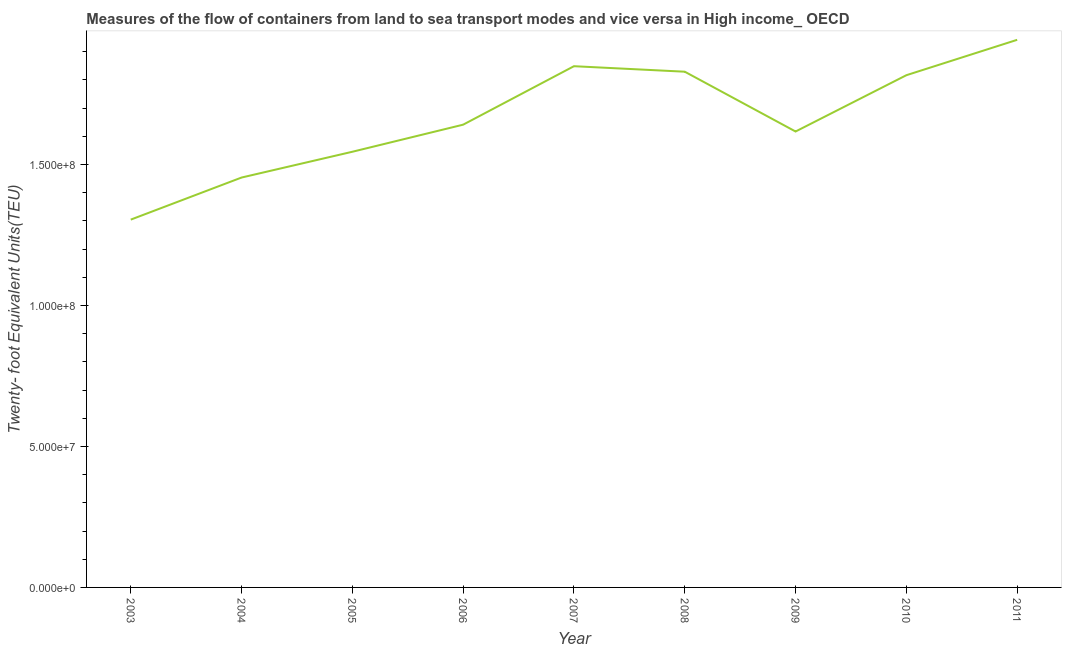What is the container port traffic in 2006?
Keep it short and to the point. 1.64e+08. Across all years, what is the maximum container port traffic?
Your answer should be compact. 1.94e+08. Across all years, what is the minimum container port traffic?
Offer a very short reply. 1.30e+08. In which year was the container port traffic maximum?
Make the answer very short. 2011. In which year was the container port traffic minimum?
Provide a succinct answer. 2003. What is the sum of the container port traffic?
Offer a terse response. 1.50e+09. What is the difference between the container port traffic in 2009 and 2010?
Your answer should be compact. -2.00e+07. What is the average container port traffic per year?
Your answer should be very brief. 1.67e+08. What is the median container port traffic?
Keep it short and to the point. 1.64e+08. What is the ratio of the container port traffic in 2010 to that in 2011?
Your answer should be very brief. 0.94. Is the container port traffic in 2003 less than that in 2007?
Your answer should be compact. Yes. Is the difference between the container port traffic in 2007 and 2009 greater than the difference between any two years?
Your answer should be very brief. No. What is the difference between the highest and the second highest container port traffic?
Give a very brief answer. 9.36e+06. Is the sum of the container port traffic in 2007 and 2011 greater than the maximum container port traffic across all years?
Your answer should be compact. Yes. What is the difference between the highest and the lowest container port traffic?
Provide a short and direct response. 6.38e+07. How many lines are there?
Your answer should be compact. 1. How many years are there in the graph?
Your response must be concise. 9. Are the values on the major ticks of Y-axis written in scientific E-notation?
Provide a short and direct response. Yes. Does the graph contain any zero values?
Make the answer very short. No. What is the title of the graph?
Your response must be concise. Measures of the flow of containers from land to sea transport modes and vice versa in High income_ OECD. What is the label or title of the Y-axis?
Your answer should be compact. Twenty- foot Equivalent Units(TEU). What is the Twenty- foot Equivalent Units(TEU) in 2003?
Keep it short and to the point. 1.30e+08. What is the Twenty- foot Equivalent Units(TEU) in 2004?
Make the answer very short. 1.45e+08. What is the Twenty- foot Equivalent Units(TEU) of 2005?
Make the answer very short. 1.55e+08. What is the Twenty- foot Equivalent Units(TEU) of 2006?
Your answer should be very brief. 1.64e+08. What is the Twenty- foot Equivalent Units(TEU) of 2007?
Offer a terse response. 1.85e+08. What is the Twenty- foot Equivalent Units(TEU) of 2008?
Provide a succinct answer. 1.83e+08. What is the Twenty- foot Equivalent Units(TEU) of 2009?
Provide a succinct answer. 1.62e+08. What is the Twenty- foot Equivalent Units(TEU) of 2010?
Give a very brief answer. 1.82e+08. What is the Twenty- foot Equivalent Units(TEU) in 2011?
Provide a succinct answer. 1.94e+08. What is the difference between the Twenty- foot Equivalent Units(TEU) in 2003 and 2004?
Provide a short and direct response. -1.49e+07. What is the difference between the Twenty- foot Equivalent Units(TEU) in 2003 and 2005?
Make the answer very short. -2.41e+07. What is the difference between the Twenty- foot Equivalent Units(TEU) in 2003 and 2006?
Your answer should be compact. -3.37e+07. What is the difference between the Twenty- foot Equivalent Units(TEU) in 2003 and 2007?
Make the answer very short. -5.44e+07. What is the difference between the Twenty- foot Equivalent Units(TEU) in 2003 and 2008?
Keep it short and to the point. -5.25e+07. What is the difference between the Twenty- foot Equivalent Units(TEU) in 2003 and 2009?
Provide a succinct answer. -3.13e+07. What is the difference between the Twenty- foot Equivalent Units(TEU) in 2003 and 2010?
Your answer should be very brief. -5.12e+07. What is the difference between the Twenty- foot Equivalent Units(TEU) in 2003 and 2011?
Your answer should be very brief. -6.38e+07. What is the difference between the Twenty- foot Equivalent Units(TEU) in 2004 and 2005?
Offer a terse response. -9.14e+06. What is the difference between the Twenty- foot Equivalent Units(TEU) in 2004 and 2006?
Keep it short and to the point. -1.88e+07. What is the difference between the Twenty- foot Equivalent Units(TEU) in 2004 and 2007?
Give a very brief answer. -3.95e+07. What is the difference between the Twenty- foot Equivalent Units(TEU) in 2004 and 2008?
Keep it short and to the point. -3.75e+07. What is the difference between the Twenty- foot Equivalent Units(TEU) in 2004 and 2009?
Keep it short and to the point. -1.63e+07. What is the difference between the Twenty- foot Equivalent Units(TEU) in 2004 and 2010?
Your answer should be very brief. -3.63e+07. What is the difference between the Twenty- foot Equivalent Units(TEU) in 2004 and 2011?
Your answer should be compact. -4.88e+07. What is the difference between the Twenty- foot Equivalent Units(TEU) in 2005 and 2006?
Keep it short and to the point. -9.61e+06. What is the difference between the Twenty- foot Equivalent Units(TEU) in 2005 and 2007?
Your response must be concise. -3.03e+07. What is the difference between the Twenty- foot Equivalent Units(TEU) in 2005 and 2008?
Provide a succinct answer. -2.84e+07. What is the difference between the Twenty- foot Equivalent Units(TEU) in 2005 and 2009?
Make the answer very short. -7.18e+06. What is the difference between the Twenty- foot Equivalent Units(TEU) in 2005 and 2010?
Make the answer very short. -2.72e+07. What is the difference between the Twenty- foot Equivalent Units(TEU) in 2005 and 2011?
Provide a succinct answer. -3.97e+07. What is the difference between the Twenty- foot Equivalent Units(TEU) in 2006 and 2007?
Give a very brief answer. -2.07e+07. What is the difference between the Twenty- foot Equivalent Units(TEU) in 2006 and 2008?
Give a very brief answer. -1.88e+07. What is the difference between the Twenty- foot Equivalent Units(TEU) in 2006 and 2009?
Give a very brief answer. 2.42e+06. What is the difference between the Twenty- foot Equivalent Units(TEU) in 2006 and 2010?
Offer a terse response. -1.75e+07. What is the difference between the Twenty- foot Equivalent Units(TEU) in 2006 and 2011?
Your answer should be very brief. -3.01e+07. What is the difference between the Twenty- foot Equivalent Units(TEU) in 2007 and 2008?
Ensure brevity in your answer.  1.95e+06. What is the difference between the Twenty- foot Equivalent Units(TEU) in 2007 and 2009?
Ensure brevity in your answer.  2.32e+07. What is the difference between the Twenty- foot Equivalent Units(TEU) in 2007 and 2010?
Make the answer very short. 3.19e+06. What is the difference between the Twenty- foot Equivalent Units(TEU) in 2007 and 2011?
Keep it short and to the point. -9.36e+06. What is the difference between the Twenty- foot Equivalent Units(TEU) in 2008 and 2009?
Offer a very short reply. 2.12e+07. What is the difference between the Twenty- foot Equivalent Units(TEU) in 2008 and 2010?
Offer a terse response. 1.24e+06. What is the difference between the Twenty- foot Equivalent Units(TEU) in 2008 and 2011?
Give a very brief answer. -1.13e+07. What is the difference between the Twenty- foot Equivalent Units(TEU) in 2009 and 2010?
Your response must be concise. -2.00e+07. What is the difference between the Twenty- foot Equivalent Units(TEU) in 2009 and 2011?
Keep it short and to the point. -3.25e+07. What is the difference between the Twenty- foot Equivalent Units(TEU) in 2010 and 2011?
Your answer should be very brief. -1.25e+07. What is the ratio of the Twenty- foot Equivalent Units(TEU) in 2003 to that in 2004?
Your answer should be compact. 0.9. What is the ratio of the Twenty- foot Equivalent Units(TEU) in 2003 to that in 2005?
Offer a terse response. 0.84. What is the ratio of the Twenty- foot Equivalent Units(TEU) in 2003 to that in 2006?
Provide a succinct answer. 0.8. What is the ratio of the Twenty- foot Equivalent Units(TEU) in 2003 to that in 2007?
Your response must be concise. 0.71. What is the ratio of the Twenty- foot Equivalent Units(TEU) in 2003 to that in 2008?
Ensure brevity in your answer.  0.71. What is the ratio of the Twenty- foot Equivalent Units(TEU) in 2003 to that in 2009?
Your response must be concise. 0.81. What is the ratio of the Twenty- foot Equivalent Units(TEU) in 2003 to that in 2010?
Provide a succinct answer. 0.72. What is the ratio of the Twenty- foot Equivalent Units(TEU) in 2003 to that in 2011?
Offer a very short reply. 0.67. What is the ratio of the Twenty- foot Equivalent Units(TEU) in 2004 to that in 2005?
Your response must be concise. 0.94. What is the ratio of the Twenty- foot Equivalent Units(TEU) in 2004 to that in 2006?
Make the answer very short. 0.89. What is the ratio of the Twenty- foot Equivalent Units(TEU) in 2004 to that in 2007?
Offer a very short reply. 0.79. What is the ratio of the Twenty- foot Equivalent Units(TEU) in 2004 to that in 2008?
Make the answer very short. 0.8. What is the ratio of the Twenty- foot Equivalent Units(TEU) in 2004 to that in 2009?
Offer a very short reply. 0.9. What is the ratio of the Twenty- foot Equivalent Units(TEU) in 2004 to that in 2011?
Offer a terse response. 0.75. What is the ratio of the Twenty- foot Equivalent Units(TEU) in 2005 to that in 2006?
Offer a very short reply. 0.94. What is the ratio of the Twenty- foot Equivalent Units(TEU) in 2005 to that in 2007?
Give a very brief answer. 0.84. What is the ratio of the Twenty- foot Equivalent Units(TEU) in 2005 to that in 2008?
Offer a very short reply. 0.84. What is the ratio of the Twenty- foot Equivalent Units(TEU) in 2005 to that in 2009?
Your answer should be compact. 0.96. What is the ratio of the Twenty- foot Equivalent Units(TEU) in 2005 to that in 2010?
Give a very brief answer. 0.85. What is the ratio of the Twenty- foot Equivalent Units(TEU) in 2005 to that in 2011?
Keep it short and to the point. 0.8. What is the ratio of the Twenty- foot Equivalent Units(TEU) in 2006 to that in 2007?
Offer a very short reply. 0.89. What is the ratio of the Twenty- foot Equivalent Units(TEU) in 2006 to that in 2008?
Make the answer very short. 0.9. What is the ratio of the Twenty- foot Equivalent Units(TEU) in 2006 to that in 2010?
Keep it short and to the point. 0.9. What is the ratio of the Twenty- foot Equivalent Units(TEU) in 2006 to that in 2011?
Your response must be concise. 0.84. What is the ratio of the Twenty- foot Equivalent Units(TEU) in 2007 to that in 2008?
Ensure brevity in your answer.  1.01. What is the ratio of the Twenty- foot Equivalent Units(TEU) in 2007 to that in 2009?
Provide a short and direct response. 1.14. What is the ratio of the Twenty- foot Equivalent Units(TEU) in 2007 to that in 2011?
Offer a terse response. 0.95. What is the ratio of the Twenty- foot Equivalent Units(TEU) in 2008 to that in 2009?
Your response must be concise. 1.13. What is the ratio of the Twenty- foot Equivalent Units(TEU) in 2008 to that in 2010?
Provide a succinct answer. 1.01. What is the ratio of the Twenty- foot Equivalent Units(TEU) in 2008 to that in 2011?
Provide a succinct answer. 0.94. What is the ratio of the Twenty- foot Equivalent Units(TEU) in 2009 to that in 2010?
Your answer should be very brief. 0.89. What is the ratio of the Twenty- foot Equivalent Units(TEU) in 2009 to that in 2011?
Your response must be concise. 0.83. What is the ratio of the Twenty- foot Equivalent Units(TEU) in 2010 to that in 2011?
Your response must be concise. 0.94. 